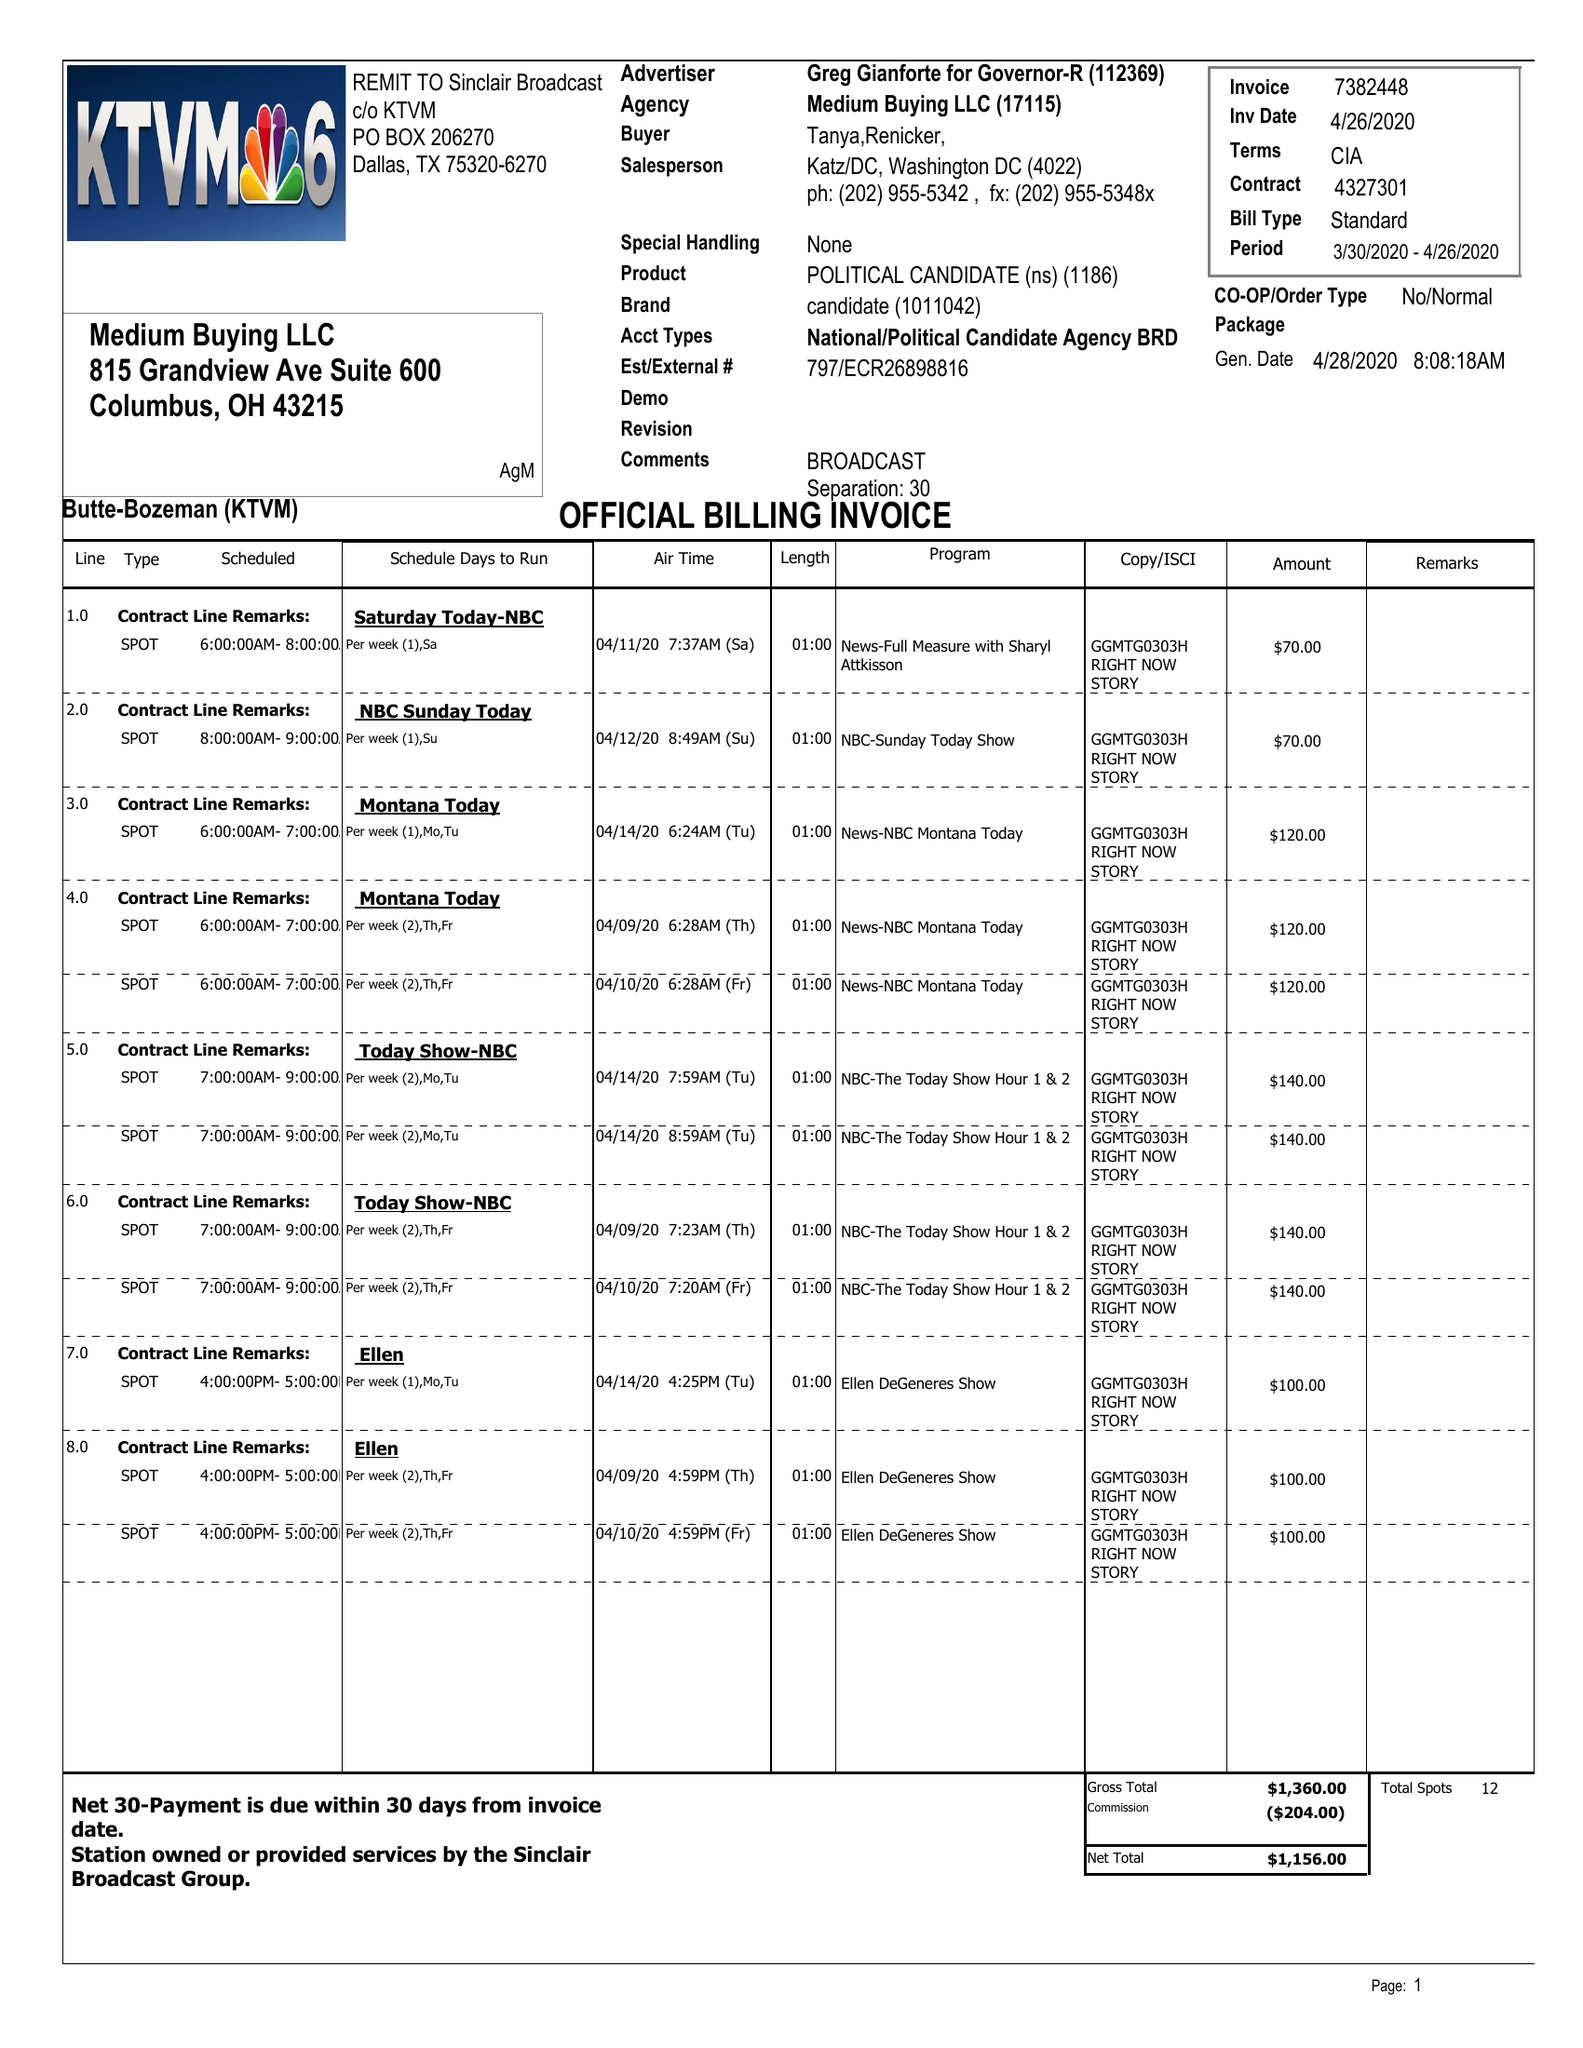What is the value for the advertiser?
Answer the question using a single word or phrase. GREG GIANFORTE FOR GOVERNOR-R 